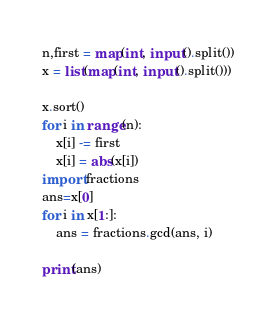Convert code to text. <code><loc_0><loc_0><loc_500><loc_500><_Python_>n,first = map(int, input().split())
x = list(map(int, input().split()))

x.sort()
for i in range(n):
    x[i] -= first
    x[i] = abs(x[i])
import fractions
ans=x[0]
for i in x[1:]:
    ans = fractions.gcd(ans, i)

print(ans)</code> 